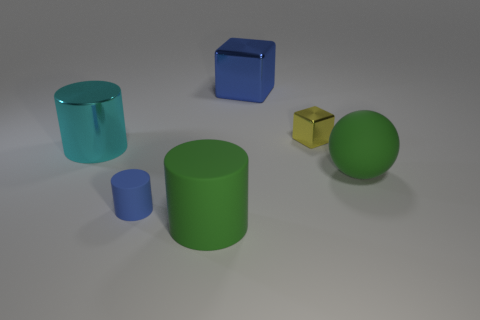How many yellow cubes are on the left side of the blue matte cylinder?
Provide a short and direct response. 0. There is a small thing in front of the small thing that is behind the big cyan cylinder; what is it made of?
Provide a short and direct response. Rubber. Is there any other thing that has the same size as the sphere?
Offer a terse response. Yes. Do the cyan metal cylinder and the rubber sphere have the same size?
Provide a succinct answer. Yes. How many things are matte objects that are left of the large blue cube or green matte things that are to the left of the tiny yellow thing?
Your response must be concise. 2. Is the number of big green objects to the right of the large blue thing greater than the number of purple metal cubes?
Keep it short and to the point. Yes. What number of other objects are the same shape as the tiny blue object?
Make the answer very short. 2. The thing that is both right of the blue cube and in front of the yellow block is made of what material?
Your response must be concise. Rubber. How many objects are either cubes or red cylinders?
Your answer should be very brief. 2. Are there more big metallic cubes than tiny gray rubber objects?
Your answer should be very brief. Yes. 